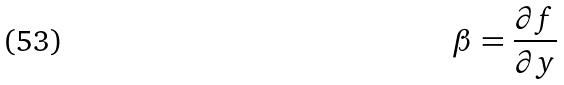Convert formula to latex. <formula><loc_0><loc_0><loc_500><loc_500>\beta = \frac { \partial f } { \partial y }</formula> 